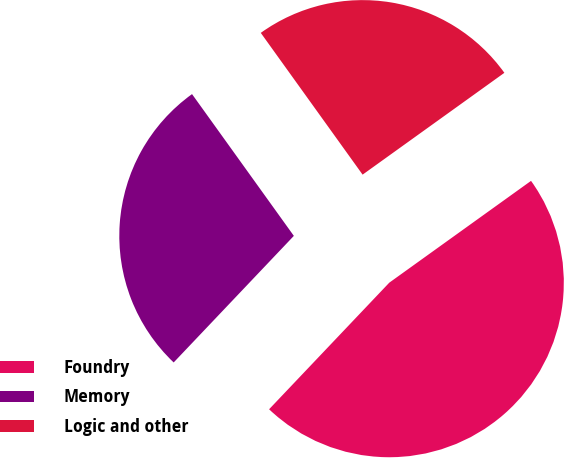Convert chart to OTSL. <chart><loc_0><loc_0><loc_500><loc_500><pie_chart><fcel>Foundry<fcel>Memory<fcel>Logic and other<nl><fcel>47.0%<fcel>28.0%<fcel>25.0%<nl></chart> 